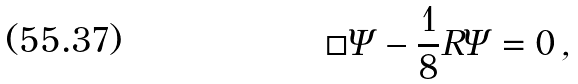Convert formula to latex. <formula><loc_0><loc_0><loc_500><loc_500>\Box \Psi - \frac { 1 } { 8 } R \Psi = 0 \, ,</formula> 